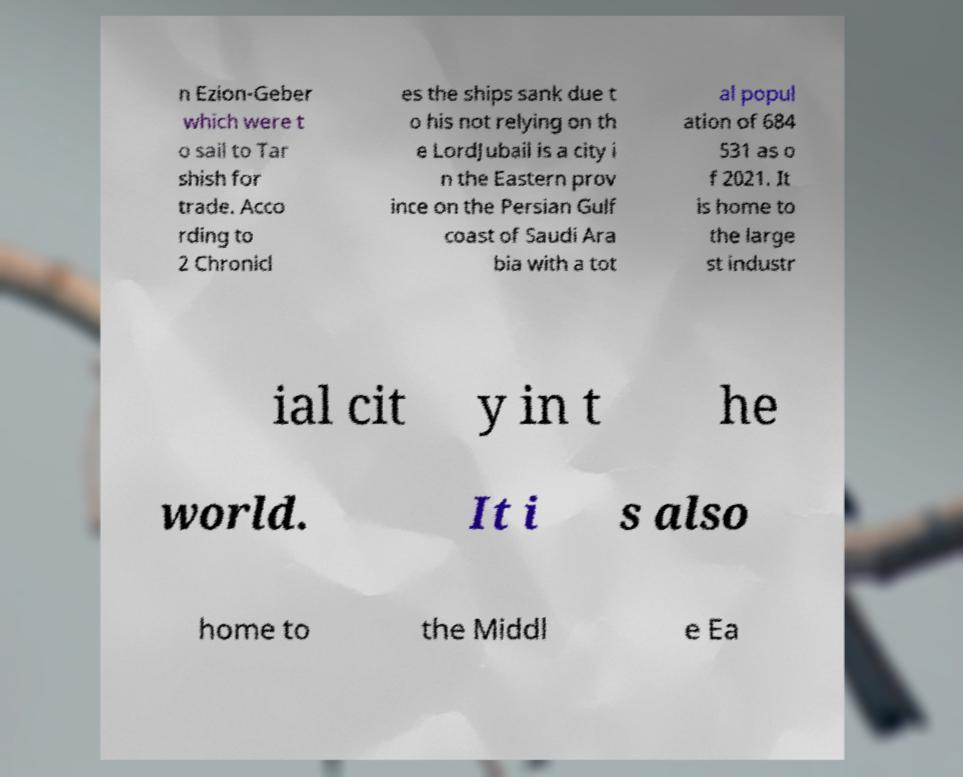Can you read and provide the text displayed in the image?This photo seems to have some interesting text. Can you extract and type it out for me? n Ezion-Geber which were t o sail to Tar shish for trade. Acco rding to 2 Chronicl es the ships sank due t o his not relying on th e LordJubail is a city i n the Eastern prov ince on the Persian Gulf coast of Saudi Ara bia with a tot al popul ation of 684 531 as o f 2021. It is home to the large st industr ial cit y in t he world. It i s also home to the Middl e Ea 